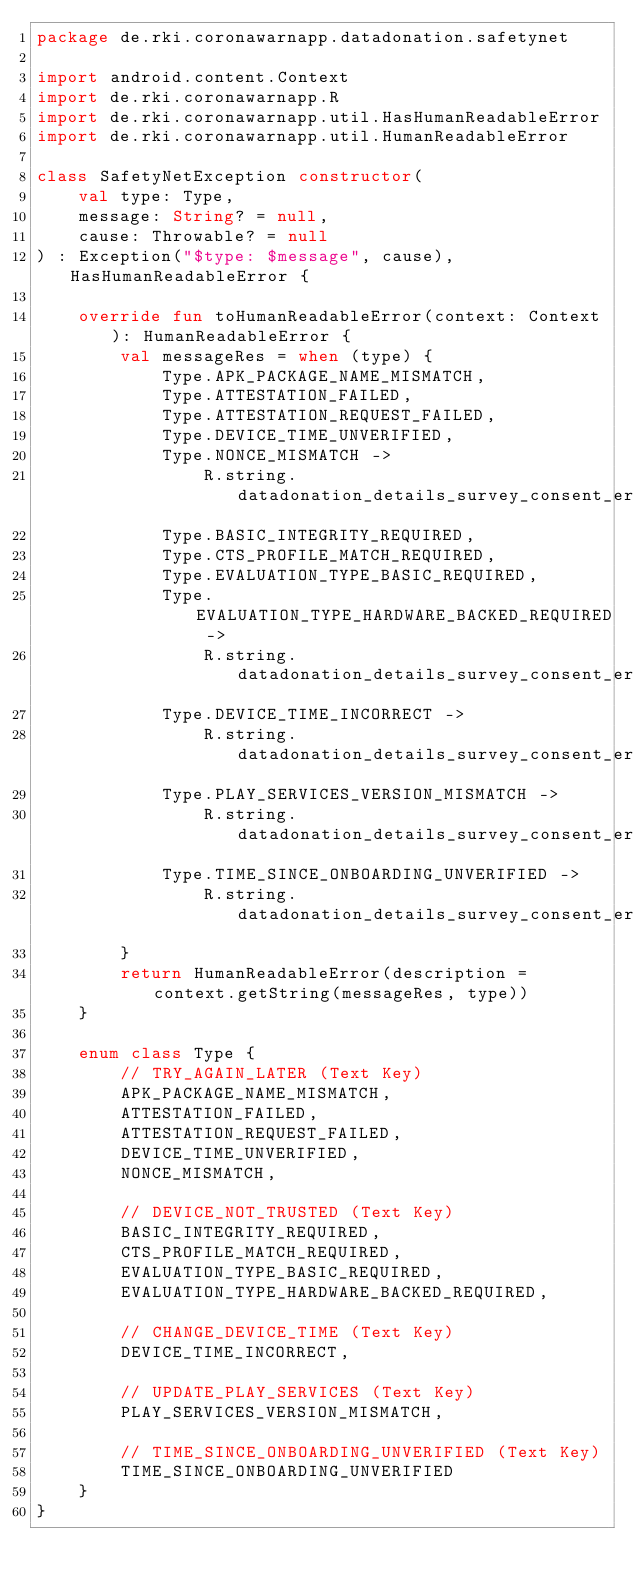<code> <loc_0><loc_0><loc_500><loc_500><_Kotlin_>package de.rki.coronawarnapp.datadonation.safetynet

import android.content.Context
import de.rki.coronawarnapp.R
import de.rki.coronawarnapp.util.HasHumanReadableError
import de.rki.coronawarnapp.util.HumanReadableError

class SafetyNetException constructor(
    val type: Type,
    message: String? = null,
    cause: Throwable? = null
) : Exception("$type: $message", cause), HasHumanReadableError {

    override fun toHumanReadableError(context: Context): HumanReadableError {
        val messageRes = when (type) {
            Type.APK_PACKAGE_NAME_MISMATCH,
            Type.ATTESTATION_FAILED,
            Type.ATTESTATION_REQUEST_FAILED,
            Type.DEVICE_TIME_UNVERIFIED,
            Type.NONCE_MISMATCH ->
                R.string.datadonation_details_survey_consent_error_TRY_AGAIN_LATER
            Type.BASIC_INTEGRITY_REQUIRED,
            Type.CTS_PROFILE_MATCH_REQUIRED,
            Type.EVALUATION_TYPE_BASIC_REQUIRED,
            Type.EVALUATION_TYPE_HARDWARE_BACKED_REQUIRED ->
                R.string.datadonation_details_survey_consent_error_DEVICE_NOT_TRUSTED
            Type.DEVICE_TIME_INCORRECT ->
                R.string.datadonation_details_survey_consent_error_CHANGE_DEVICE_TIME
            Type.PLAY_SERVICES_VERSION_MISMATCH ->
                R.string.datadonation_details_survey_consent_error_UPDATE_PLAY_SERVICES
            Type.TIME_SINCE_ONBOARDING_UNVERIFIED ->
                R.string.datadonation_details_survey_consent_error_TIME_SINCE_ONBOARDING_UNVERIFIED
        }
        return HumanReadableError(description = context.getString(messageRes, type))
    }

    enum class Type {
        // TRY_AGAIN_LATER (Text Key)
        APK_PACKAGE_NAME_MISMATCH,
        ATTESTATION_FAILED,
        ATTESTATION_REQUEST_FAILED,
        DEVICE_TIME_UNVERIFIED,
        NONCE_MISMATCH,

        // DEVICE_NOT_TRUSTED (Text Key)
        BASIC_INTEGRITY_REQUIRED,
        CTS_PROFILE_MATCH_REQUIRED,
        EVALUATION_TYPE_BASIC_REQUIRED,
        EVALUATION_TYPE_HARDWARE_BACKED_REQUIRED,

        // CHANGE_DEVICE_TIME (Text Key)
        DEVICE_TIME_INCORRECT,

        // UPDATE_PLAY_SERVICES (Text Key)
        PLAY_SERVICES_VERSION_MISMATCH,

        // TIME_SINCE_ONBOARDING_UNVERIFIED (Text Key)
        TIME_SINCE_ONBOARDING_UNVERIFIED
    }
}
</code> 